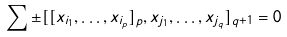<formula> <loc_0><loc_0><loc_500><loc_500>\sum \pm [ [ x _ { i _ { 1 } } , \dots , x _ { i _ { p } } ] _ { p } , x _ { j _ { 1 } } , \dots , x _ { j _ { q } } ] _ { q + 1 } = 0</formula> 